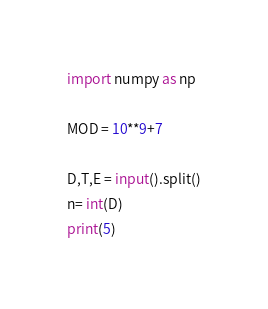Convert code to text. <code><loc_0><loc_0><loc_500><loc_500><_Python_>import numpy as np

MOD = 10**9+7

D,T,E = input().split()
n= int(D)
print(5)</code> 